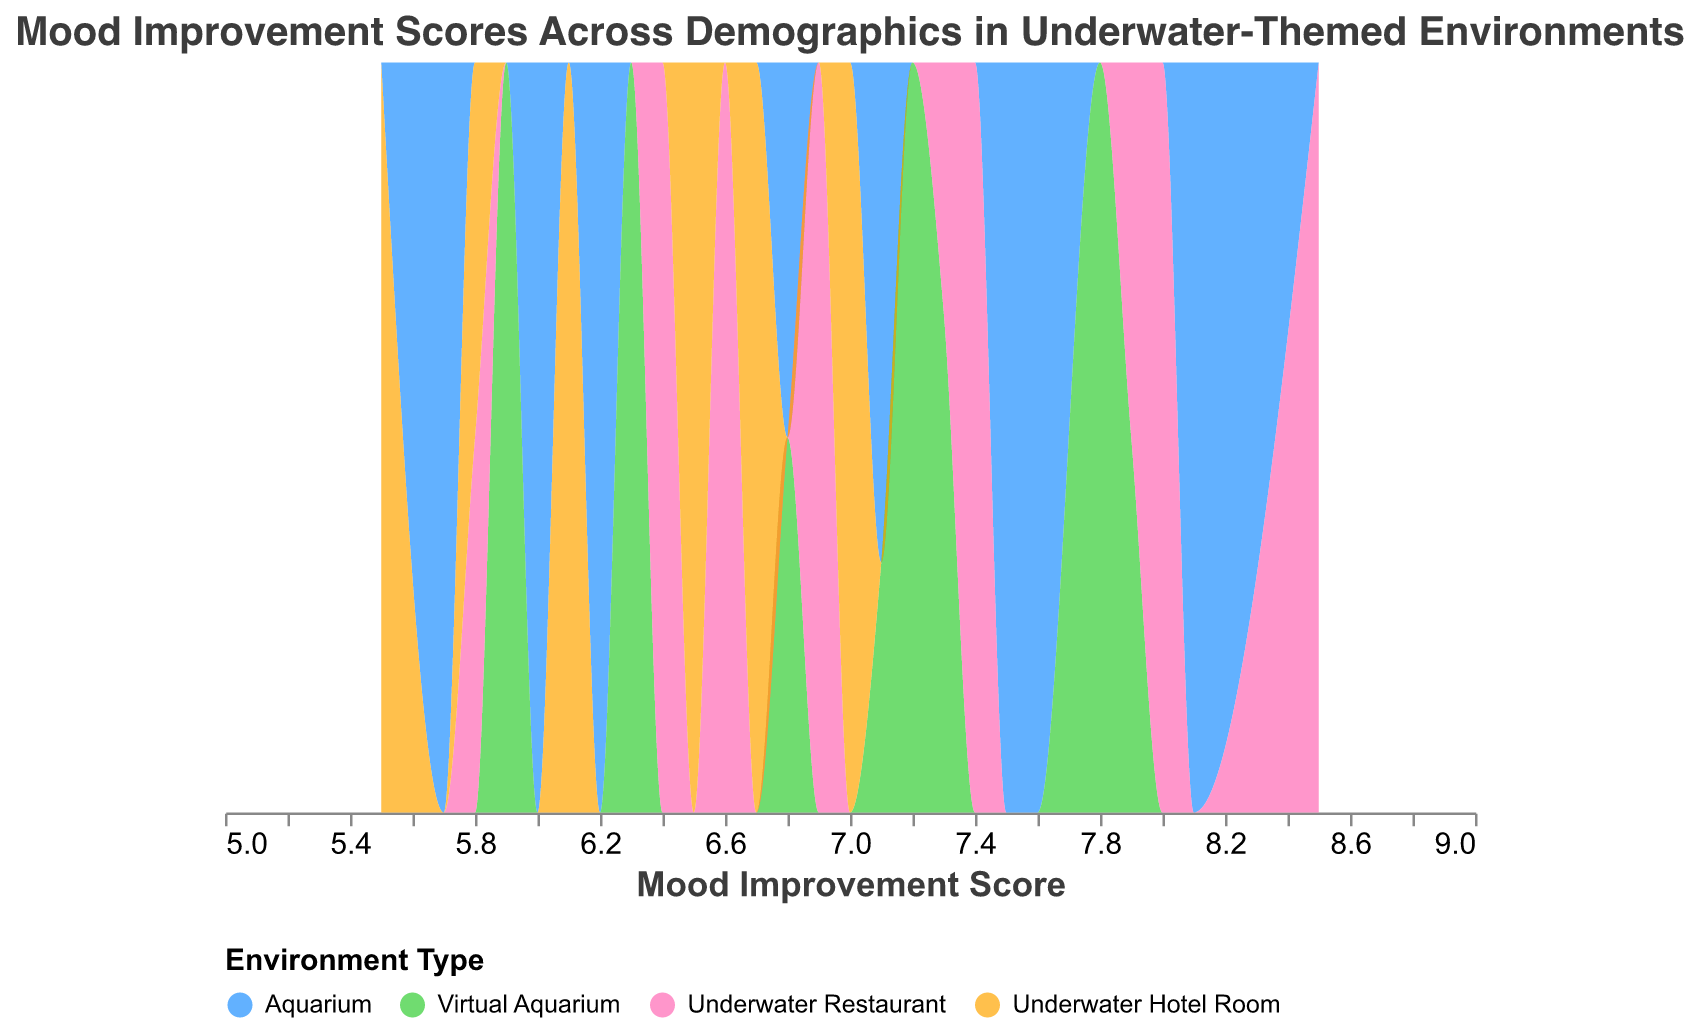What is the title of the plot? The title of the plot is usually found at the top of the figure, and it gives a summary of what the plot is about. In this case, the title is "Mood Improvement Scores Across Demographics in Underwater-Themed Environments."
Answer: Mood Improvement Scores Across Demographics in Underwater-Themed Environments What is represented on the x-axis of the plot? The x-axis usually represents a quantitative variable. In this figure, it represents "Mood Improvement Score."
Answer: Mood Improvement Score What are the different categories represented by different colors? Colors in the plot represent different categories based on the "Environment Type" field. The legend at the bottom helps identify these colors. The categories are Aquarium, Virtual Aquarium, Underwater Restaurant, and Underwater Hotel Room.
Answer: Aquarium, Virtual Aquarium, Underwater Restaurant, Underwater Hotel Room Which environment type has the highest peak in mood improvement scores? By observing the density plot, the environment type with the highest peak for mood improvement scores is identified by looking at which color has the highest point along the x-axis. This is the Underwater Restaurant (pink color).
Answer: Underwater Restaurant How does the mood improvement score distribution of the Aquarium compare to that of the Virtual Aquarium? To compare the distributions, observe the density curves of both the Aquarium (blue color) and Virtual Aquarium (green color). The Aquarium tends to have higher mood improvement scores with peaks more towards the right, while Virtual Aquarium has a wider spread with lower peaks.
Answer: Aquarium has higher mood improvement scores with peaks more towards the right compared to Virtual Aquarium What is the most common mood improvement score range for people who experienced an Underwater Hotel Room? By looking at the orange color distribution on the density plot, the most common mood improvement score range for Underwater Hotel Room appears to be around the lower scores, mostly between 5.5 to 6.5.
Answer: 5.5 to 6.5 Which environment type shows the widest distribution in mood improvement scores? A wider distribution can be identified by observing which color has the broadest spread along the x-axis. Virtual Aquarium (green color) shows the widest distribution.
Answer: Virtual Aquarium Which environment type shows the narrowest distribution in mood improvement scores? The narrowest distribution can be identified by observing which color has the least spread along the x-axis. Underwater Hotel Room (orange color) shows the narrowest distribution.
Answer: Underwater Hotel Room In which environment type are mood improvement scores most densely concentrated in a single range? The environment type with the most densely concentrated scores will have a tall, narrow peak. Underwater Restaurant (pink color) has a tall, narrow peak, indicating high concentration in a single range.
Answer: Underwater Restaurant Are there more high mood improvement scores (>7) in 'Aquarium' or 'Underwater Hotel Room'? By checking the density plot, more high mood improvement scores (>7) appear in the Aquarium (blue color) distribution compared to the Underwater Hotel Room (orange color).
Answer: Aquarium 